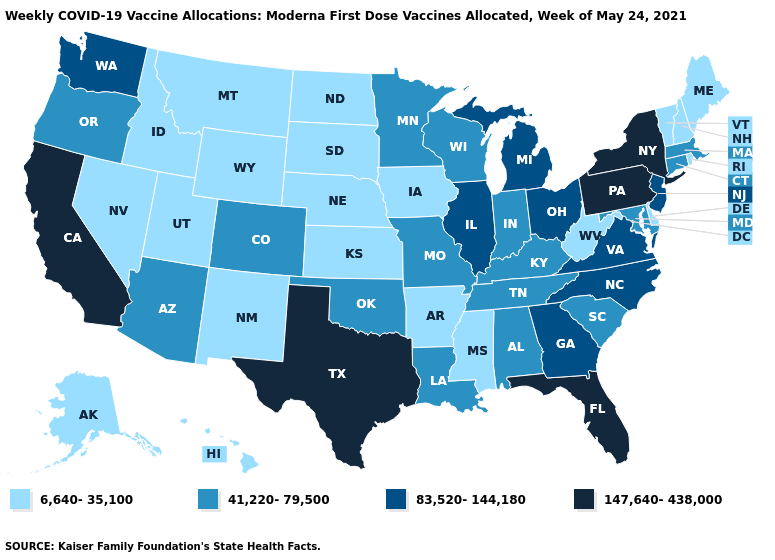Does Colorado have a lower value than Arkansas?
Write a very short answer. No. Among the states that border Iowa , which have the lowest value?
Answer briefly. Nebraska, South Dakota. Among the states that border New Hampshire , does Vermont have the highest value?
Short answer required. No. What is the value of Hawaii?
Concise answer only. 6,640-35,100. Is the legend a continuous bar?
Short answer required. No. Name the states that have a value in the range 147,640-438,000?
Short answer required. California, Florida, New York, Pennsylvania, Texas. Does New Hampshire have the highest value in the USA?
Keep it brief. No. Does the first symbol in the legend represent the smallest category?
Concise answer only. Yes. What is the highest value in the USA?
Concise answer only. 147,640-438,000. What is the lowest value in the USA?
Concise answer only. 6,640-35,100. Which states have the lowest value in the USA?
Give a very brief answer. Alaska, Arkansas, Delaware, Hawaii, Idaho, Iowa, Kansas, Maine, Mississippi, Montana, Nebraska, Nevada, New Hampshire, New Mexico, North Dakota, Rhode Island, South Dakota, Utah, Vermont, West Virginia, Wyoming. What is the value of Delaware?
Quick response, please. 6,640-35,100. Is the legend a continuous bar?
Concise answer only. No. Does Utah have the highest value in the USA?
Write a very short answer. No. 